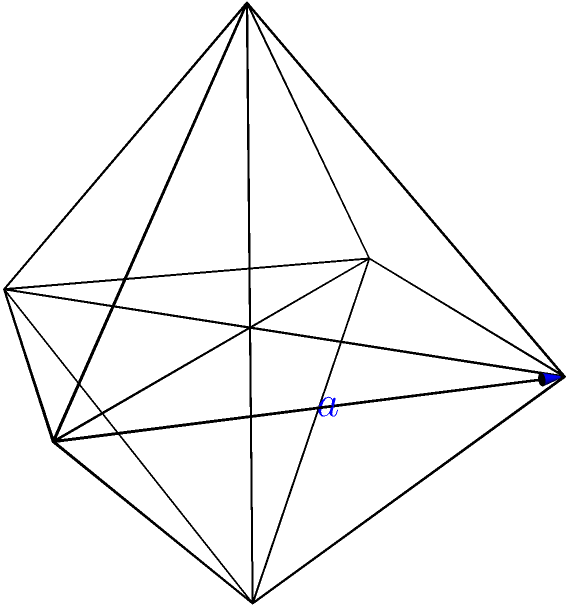In an effort to create an inclusive geometry lesson for diverse learners, you're collaborating with a rabbi to design a hands-on activity involving three-dimensional shapes. You decide to use a regular octahedron as an example. If the edge length of this regular octahedron is $a$ units, what is its total surface area in terms of $a$? Let's approach this step-by-step:

1) A regular octahedron has 8 congruent equilateral triangular faces.

2) To find the surface area, we need to calculate the area of one triangular face and multiply it by 8.

3) The area of an equilateral triangle with side length $a$ is given by:
   
   $$A = \frac{\sqrt{3}}{4}a^2$$

4) This formula comes from:
   - Height of the triangle: $h = a\frac{\sqrt{3}}{2}$
   - Area = $\frac{1}{2} \times base \times height = \frac{1}{2} \times a \times a\frac{\sqrt{3}}{2} = \frac{\sqrt{3}}{4}a^2$

5) Now, we multiply this by 8 to get the total surface area:

   $$SA = 8 \times \frac{\sqrt{3}}{4}a^2 = 2\sqrt{3}a^2$$

6) Therefore, the surface area of a regular octahedron with edge length $a$ is $2\sqrt{3}a^2$.

This approach allows learners to understand the relationship between edge length and surface area in three-dimensional shapes, promoting inclusivity by connecting geometric concepts to tangible objects.
Answer: $2\sqrt{3}a^2$ 